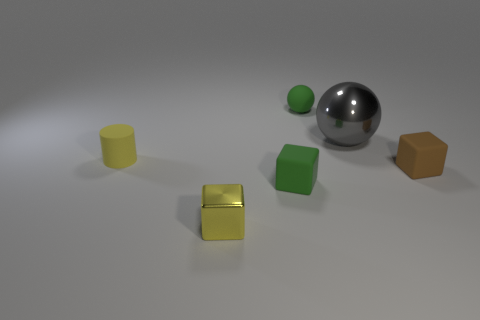Add 1 green spheres. How many objects exist? 7 Subtract all spheres. How many objects are left? 4 Add 3 small yellow metal objects. How many small yellow metal objects are left? 4 Add 6 small green objects. How many small green objects exist? 8 Subtract 0 purple blocks. How many objects are left? 6 Subtract all small brown things. Subtract all yellow matte cylinders. How many objects are left? 4 